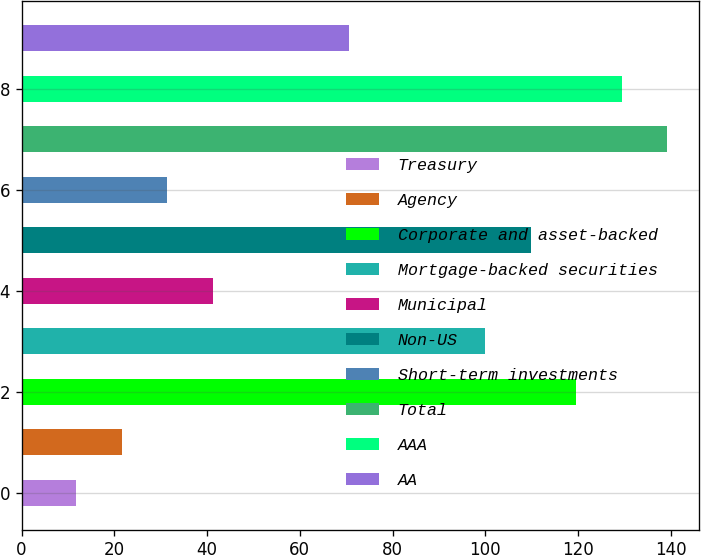Convert chart to OTSL. <chart><loc_0><loc_0><loc_500><loc_500><bar_chart><fcel>Treasury<fcel>Agency<fcel>Corporate and asset-backed<fcel>Mortgage-backed securities<fcel>Municipal<fcel>Non-US<fcel>Short-term investments<fcel>Total<fcel>AAA<fcel>AA<nl><fcel>11.8<fcel>21.6<fcel>119.6<fcel>100<fcel>41.2<fcel>109.8<fcel>31.4<fcel>139.2<fcel>129.4<fcel>70.6<nl></chart> 